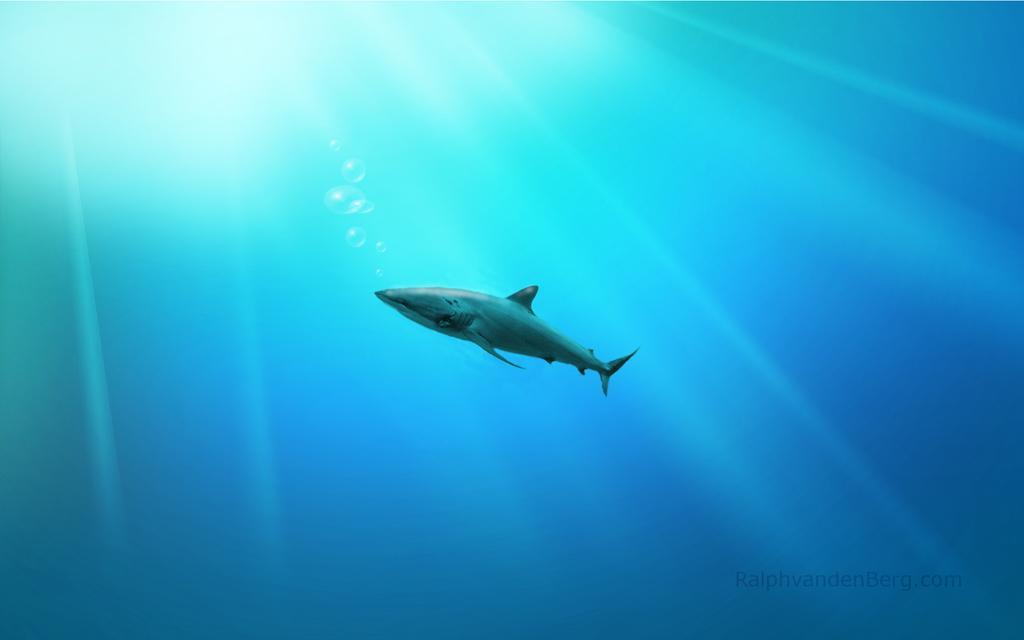How would you summarize this image in a sentence or two? This image consists of water. There is a shark in the middle. 